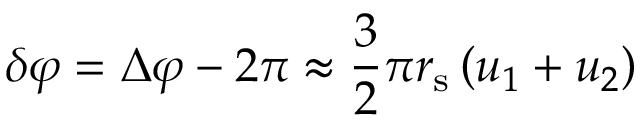<formula> <loc_0><loc_0><loc_500><loc_500>\delta \varphi = \Delta \varphi - 2 \pi \approx { \frac { 3 } { 2 } } \pi r _ { s } \left ( u _ { 1 } + u _ { 2 } \right )</formula> 